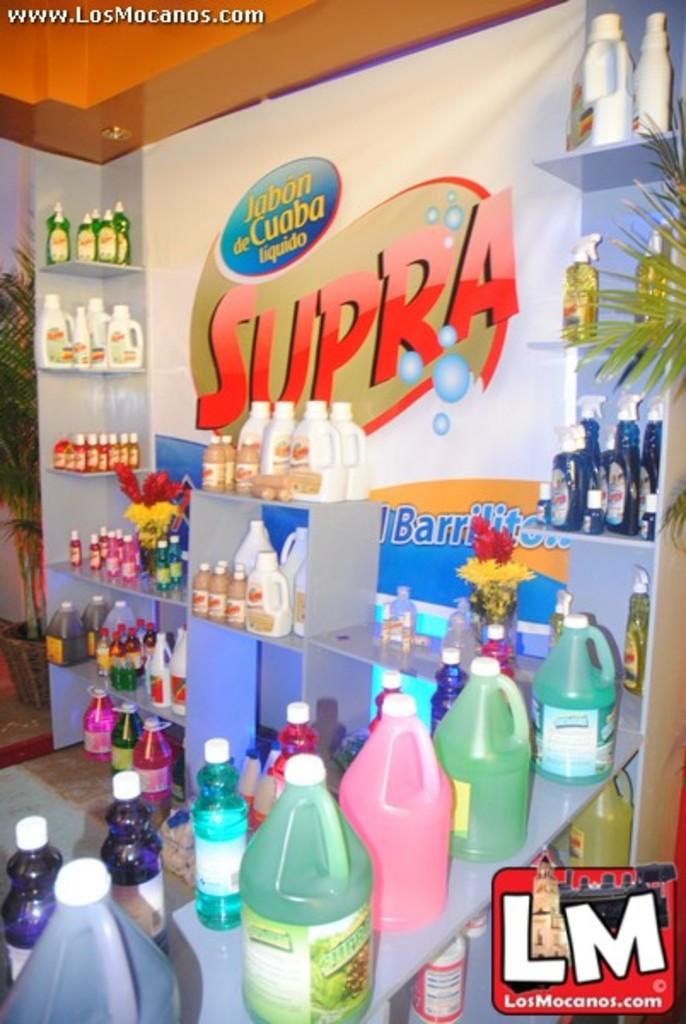<image>
Give a short and clear explanation of the subsequent image. Jabon de Cuaba liquido with website address www.LosMocanos.com 